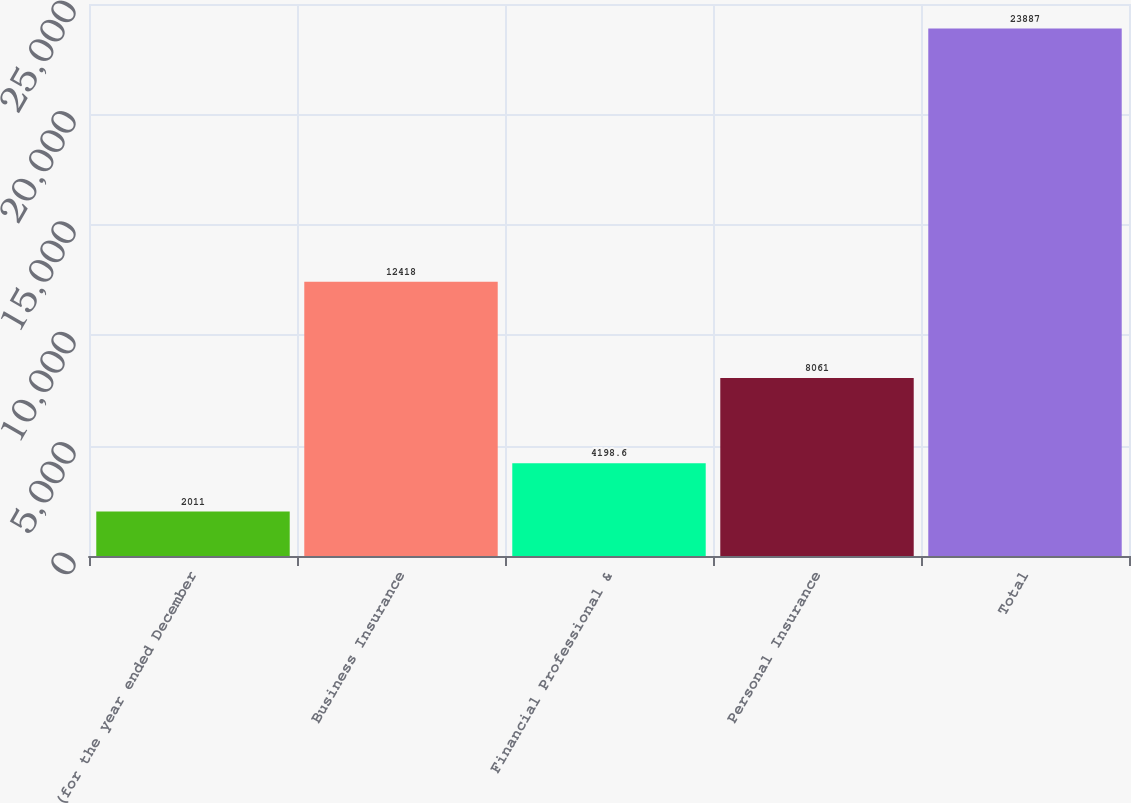<chart> <loc_0><loc_0><loc_500><loc_500><bar_chart><fcel>(for the year ended December<fcel>Business Insurance<fcel>Financial Professional &<fcel>Personal Insurance<fcel>Total<nl><fcel>2011<fcel>12418<fcel>4198.6<fcel>8061<fcel>23887<nl></chart> 